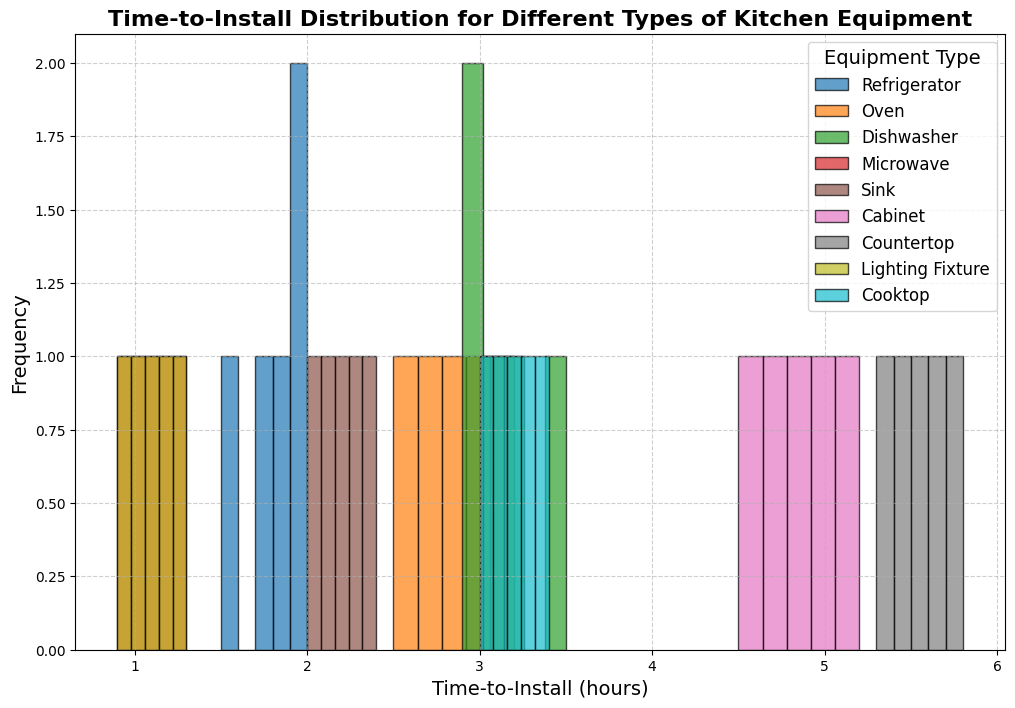What's the average time to install a microwave? First, we identify the time data for microwaves: [1.0, 1.2, 1.1, 0.9, 1.3]. Next, we sum these times: 1.0 + 1.2 + 1.1 + 0.9 + 1.3 = 5.5. Finally, we calculate the average by dividing the sum by the number of data points: 5.5 / 5 = 1.1
Answer: 1.1 Which equipment type has the most entries in the mid-range (e.g., around 3 hours)? By visually observing the histogram, we notice that "Dishwasher" and "Cooktop" have bars peaking around the 3-hour mark. However, "Dishwasher" appears to have more entries in that range.
Answer: Dishwasher Is the time-to-install for "Cabinet" generally higher or lower than for "Sink"? The histogram shows that the bar ranges for "Cabinet" (around 4.5 to 5.2 hours) are higher than those for "Sink" (around 2.0 to 2.4 hours).
Answer: Higher What's the range of time taken to install a refrigerator? From the histogram, the time for "Refrigerator" ranges from the lowest bar (1.5 hours) to the highest bar (2.0 hours).
Answer: 1.5 to 2.0 hours How many equipment types have their shortest time-to-install less than 1.5 hours? The histogram shows that "Microwave," "Lighting Fixture," and "Refrigerator" all have times less than 1.5 hours.
Answer: 3 Which equipment type shows the most variation in time-to-install? The visual spread in the histogram is widest for "Countertop," ranging from 5.3 to 5.8 hours.
Answer: Countertop What’s the median time to install an oven? The times for "Oven" are [2.5, 2.7, 2.8, 3.0, 3.2]. Sorting these, the median is the middle value, which is 2.8 hours.
Answer: 2.8 Compare the installation times between "Cooktop" and "Dishwasher." Which one generally has a higher installation time? Viewing the histogram, the installation times for "Dishwasher" (around 3.0 to 3.5 hours) are slightly higher than for "Cooktop" (around 3.0 to 3.4 hours).
Answer: Dishwasher Among all equipment types, which has the smallest installation time variance? Based on the histogram, "Microwave" shows the narrowest range of installation times (0.9 to 1.3 hours), indicating the smallest variance.
Answer: Microwave Which equipment type has the highest single frequency peak in its histogram, and what is that peak? Observing the histogram bars' heights, "Microwave" has the highest peak with the bar for the time 1.1 hours (appearing more frequently than any other single bar in any other category).
Answer: Microwave, 1.1 hours 